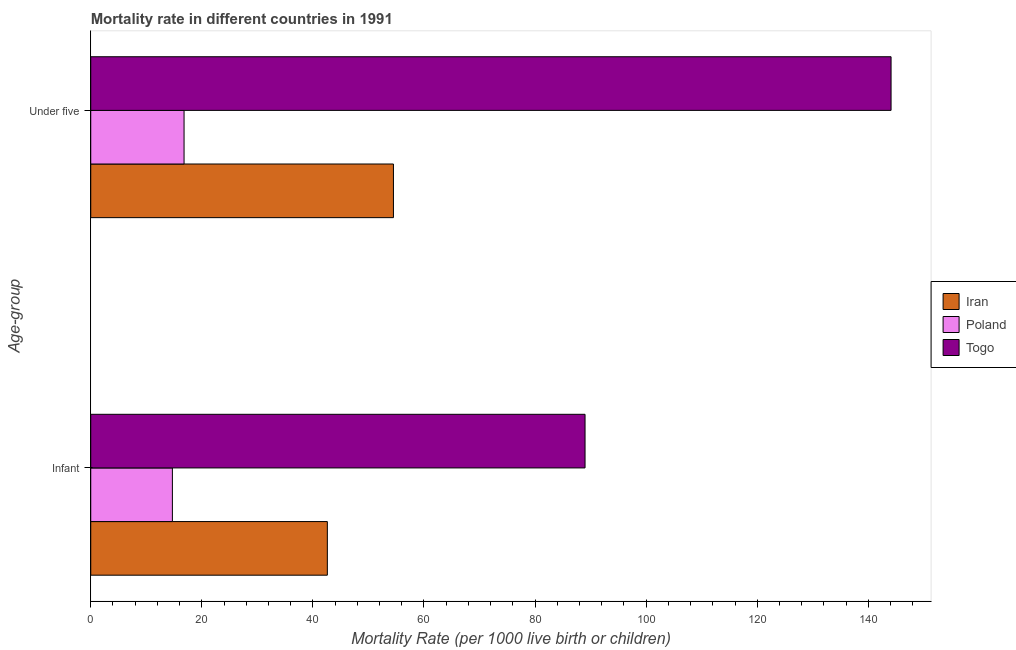How many different coloured bars are there?
Offer a terse response. 3. Are the number of bars per tick equal to the number of legend labels?
Keep it short and to the point. Yes. What is the label of the 2nd group of bars from the top?
Offer a very short reply. Infant. Across all countries, what is the maximum under-5 mortality rate?
Give a very brief answer. 144.1. Across all countries, what is the minimum infant mortality rate?
Make the answer very short. 14.7. In which country was the under-5 mortality rate maximum?
Make the answer very short. Togo. In which country was the infant mortality rate minimum?
Provide a succinct answer. Poland. What is the total infant mortality rate in the graph?
Your answer should be compact. 146.3. What is the difference between the infant mortality rate in Iran and that in Poland?
Make the answer very short. 27.9. What is the difference between the under-5 mortality rate in Togo and the infant mortality rate in Iran?
Provide a succinct answer. 101.5. What is the average infant mortality rate per country?
Give a very brief answer. 48.77. What is the difference between the infant mortality rate and under-5 mortality rate in Togo?
Keep it short and to the point. -55.1. In how many countries, is the infant mortality rate greater than 112 ?
Your answer should be very brief. 0. What is the ratio of the under-5 mortality rate in Poland to that in Iran?
Provide a succinct answer. 0.31. Is the infant mortality rate in Togo less than that in Poland?
Keep it short and to the point. No. What does the 1st bar from the top in Under five represents?
Your response must be concise. Togo. What does the 2nd bar from the bottom in Infant represents?
Provide a succinct answer. Poland. How many bars are there?
Offer a terse response. 6. Are all the bars in the graph horizontal?
Your answer should be very brief. Yes. How many countries are there in the graph?
Provide a succinct answer. 3. What is the difference between two consecutive major ticks on the X-axis?
Your answer should be very brief. 20. Does the graph contain any zero values?
Your answer should be very brief. No. How many legend labels are there?
Your answer should be very brief. 3. How are the legend labels stacked?
Provide a succinct answer. Vertical. What is the title of the graph?
Your answer should be compact. Mortality rate in different countries in 1991. Does "South Asia" appear as one of the legend labels in the graph?
Make the answer very short. No. What is the label or title of the X-axis?
Provide a short and direct response. Mortality Rate (per 1000 live birth or children). What is the label or title of the Y-axis?
Offer a terse response. Age-group. What is the Mortality Rate (per 1000 live birth or children) of Iran in Infant?
Make the answer very short. 42.6. What is the Mortality Rate (per 1000 live birth or children) in Poland in Infant?
Offer a terse response. 14.7. What is the Mortality Rate (per 1000 live birth or children) in Togo in Infant?
Make the answer very short. 89. What is the Mortality Rate (per 1000 live birth or children) in Iran in Under five?
Your answer should be compact. 54.5. What is the Mortality Rate (per 1000 live birth or children) in Poland in Under five?
Make the answer very short. 16.8. What is the Mortality Rate (per 1000 live birth or children) in Togo in Under five?
Keep it short and to the point. 144.1. Across all Age-group, what is the maximum Mortality Rate (per 1000 live birth or children) of Iran?
Give a very brief answer. 54.5. Across all Age-group, what is the maximum Mortality Rate (per 1000 live birth or children) in Togo?
Offer a very short reply. 144.1. Across all Age-group, what is the minimum Mortality Rate (per 1000 live birth or children) in Iran?
Make the answer very short. 42.6. Across all Age-group, what is the minimum Mortality Rate (per 1000 live birth or children) in Togo?
Your answer should be very brief. 89. What is the total Mortality Rate (per 1000 live birth or children) of Iran in the graph?
Offer a very short reply. 97.1. What is the total Mortality Rate (per 1000 live birth or children) in Poland in the graph?
Your answer should be very brief. 31.5. What is the total Mortality Rate (per 1000 live birth or children) in Togo in the graph?
Ensure brevity in your answer.  233.1. What is the difference between the Mortality Rate (per 1000 live birth or children) of Poland in Infant and that in Under five?
Offer a terse response. -2.1. What is the difference between the Mortality Rate (per 1000 live birth or children) in Togo in Infant and that in Under five?
Your answer should be compact. -55.1. What is the difference between the Mortality Rate (per 1000 live birth or children) in Iran in Infant and the Mortality Rate (per 1000 live birth or children) in Poland in Under five?
Give a very brief answer. 25.8. What is the difference between the Mortality Rate (per 1000 live birth or children) of Iran in Infant and the Mortality Rate (per 1000 live birth or children) of Togo in Under five?
Give a very brief answer. -101.5. What is the difference between the Mortality Rate (per 1000 live birth or children) of Poland in Infant and the Mortality Rate (per 1000 live birth or children) of Togo in Under five?
Your answer should be compact. -129.4. What is the average Mortality Rate (per 1000 live birth or children) of Iran per Age-group?
Ensure brevity in your answer.  48.55. What is the average Mortality Rate (per 1000 live birth or children) of Poland per Age-group?
Offer a very short reply. 15.75. What is the average Mortality Rate (per 1000 live birth or children) of Togo per Age-group?
Provide a short and direct response. 116.55. What is the difference between the Mortality Rate (per 1000 live birth or children) of Iran and Mortality Rate (per 1000 live birth or children) of Poland in Infant?
Your answer should be very brief. 27.9. What is the difference between the Mortality Rate (per 1000 live birth or children) of Iran and Mortality Rate (per 1000 live birth or children) of Togo in Infant?
Offer a terse response. -46.4. What is the difference between the Mortality Rate (per 1000 live birth or children) of Poland and Mortality Rate (per 1000 live birth or children) of Togo in Infant?
Your response must be concise. -74.3. What is the difference between the Mortality Rate (per 1000 live birth or children) in Iran and Mortality Rate (per 1000 live birth or children) in Poland in Under five?
Your response must be concise. 37.7. What is the difference between the Mortality Rate (per 1000 live birth or children) of Iran and Mortality Rate (per 1000 live birth or children) of Togo in Under five?
Make the answer very short. -89.6. What is the difference between the Mortality Rate (per 1000 live birth or children) of Poland and Mortality Rate (per 1000 live birth or children) of Togo in Under five?
Give a very brief answer. -127.3. What is the ratio of the Mortality Rate (per 1000 live birth or children) of Iran in Infant to that in Under five?
Your answer should be compact. 0.78. What is the ratio of the Mortality Rate (per 1000 live birth or children) in Togo in Infant to that in Under five?
Give a very brief answer. 0.62. What is the difference between the highest and the second highest Mortality Rate (per 1000 live birth or children) in Togo?
Your answer should be compact. 55.1. What is the difference between the highest and the lowest Mortality Rate (per 1000 live birth or children) of Togo?
Your answer should be compact. 55.1. 